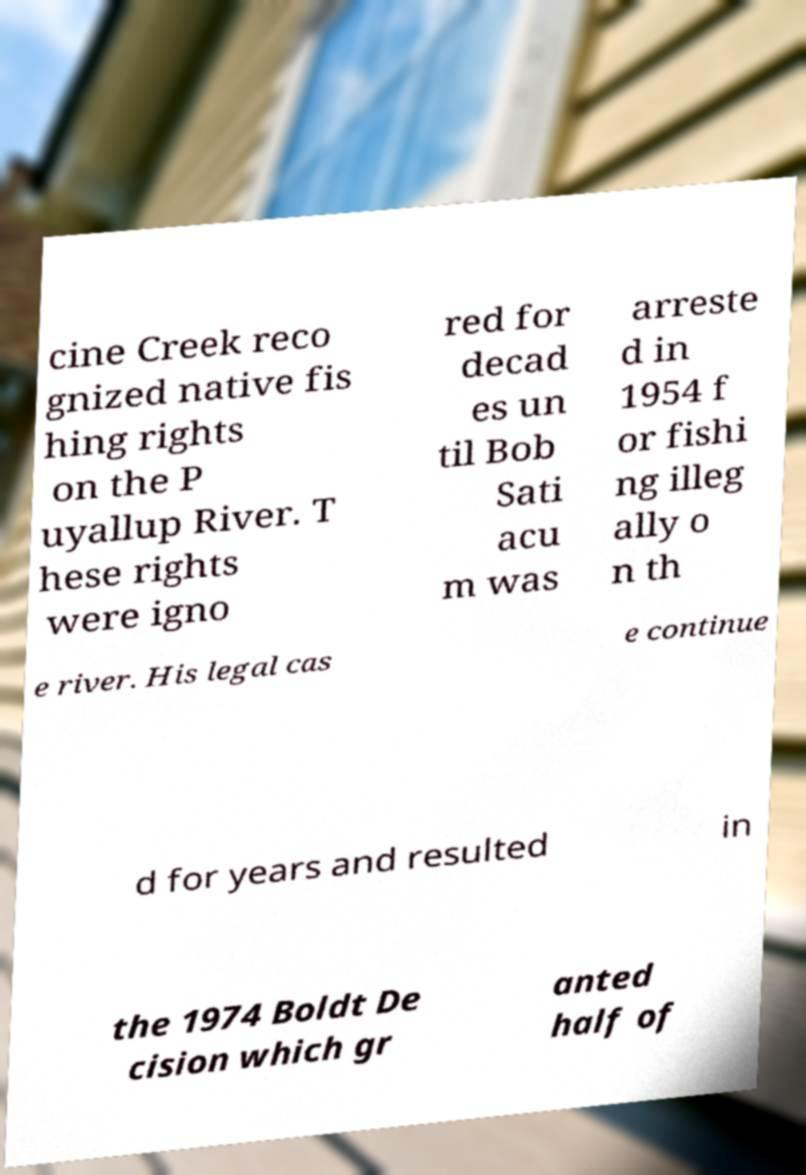Can you read and provide the text displayed in the image?This photo seems to have some interesting text. Can you extract and type it out for me? cine Creek reco gnized native fis hing rights on the P uyallup River. T hese rights were igno red for decad es un til Bob Sati acu m was arreste d in 1954 f or fishi ng illeg ally o n th e river. His legal cas e continue d for years and resulted in the 1974 Boldt De cision which gr anted half of 